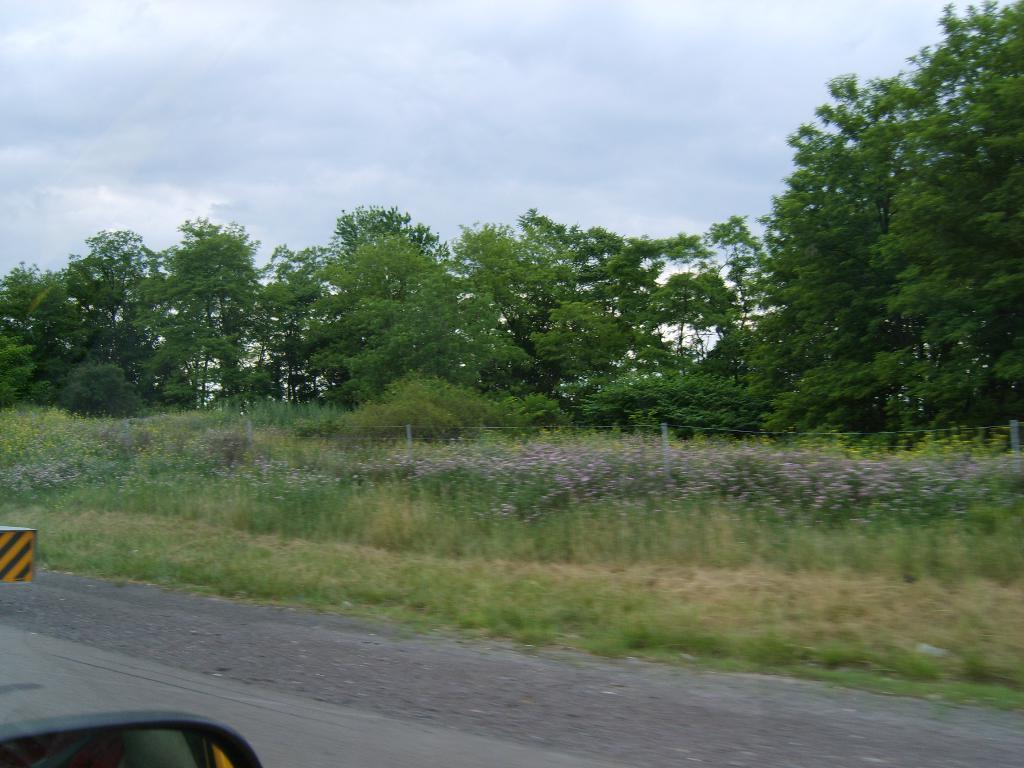Can you describe this image briefly? In this image I can see the road, background I can see the fencing, few plants and trees in green color and the sky is in white and blue color. In front I can see the mirror and some object in black and yellow color. 